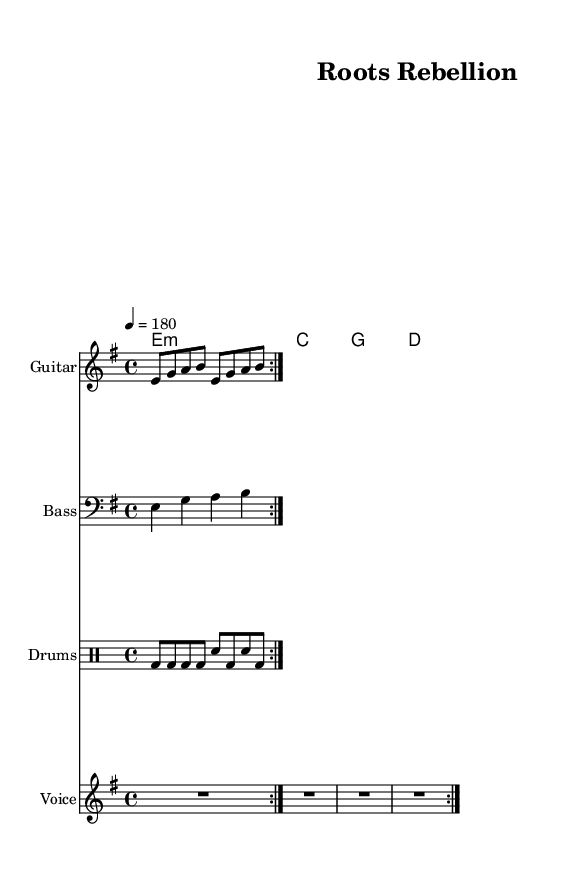What is the key signature of this music? The key signature is E minor, which contains one sharp (F#). This is identified from the global section of the LilyPond code where "\key e \minor" is specified.
Answer: E minor What is the time signature of this music? The time signature is 4/4, which is evident from the global section of the LilyPond code where "\time 4/4" is noted. This indicates there are four beats in each measure.
Answer: 4/4 What is the tempo for this piece? The tempo is set at 180 beats per minute, as stated in the global section where "\tempo 4 = 180" is specified. This means each quarter note is played at a rapid pace.
Answer: 180 What instruments are used in this music? The music features Guitar, Bass, Drums, and Voice as indicated in the Instrument names specified in each staff of the score. Each instrument has its own staff for notation.
Answer: Guitar, Bass, Drums, Voice What is the first lyric line of the verse? The first lyric line is "Scattered seeds across the sea". This can be found in the verse section of the LilyPond code under "\lyricmode" where the lyrics are defined.
Answer: Scattered seeds across the sea What is the chord progression in the chorus? The chord progression in the chorus consists of E minor, C major, G major, and D major. This is identified from the "chorusChords" section in the chordmode of the sheet music.
Answer: E minor, C, G, D How many times is the guitar riff repeated? The guitar riff is repeated two times, as indicated by the "\repeat volta 2" command in the Guitar staff section of the code, which specifies that the riff will be played twice before moving on.
Answer: 2 